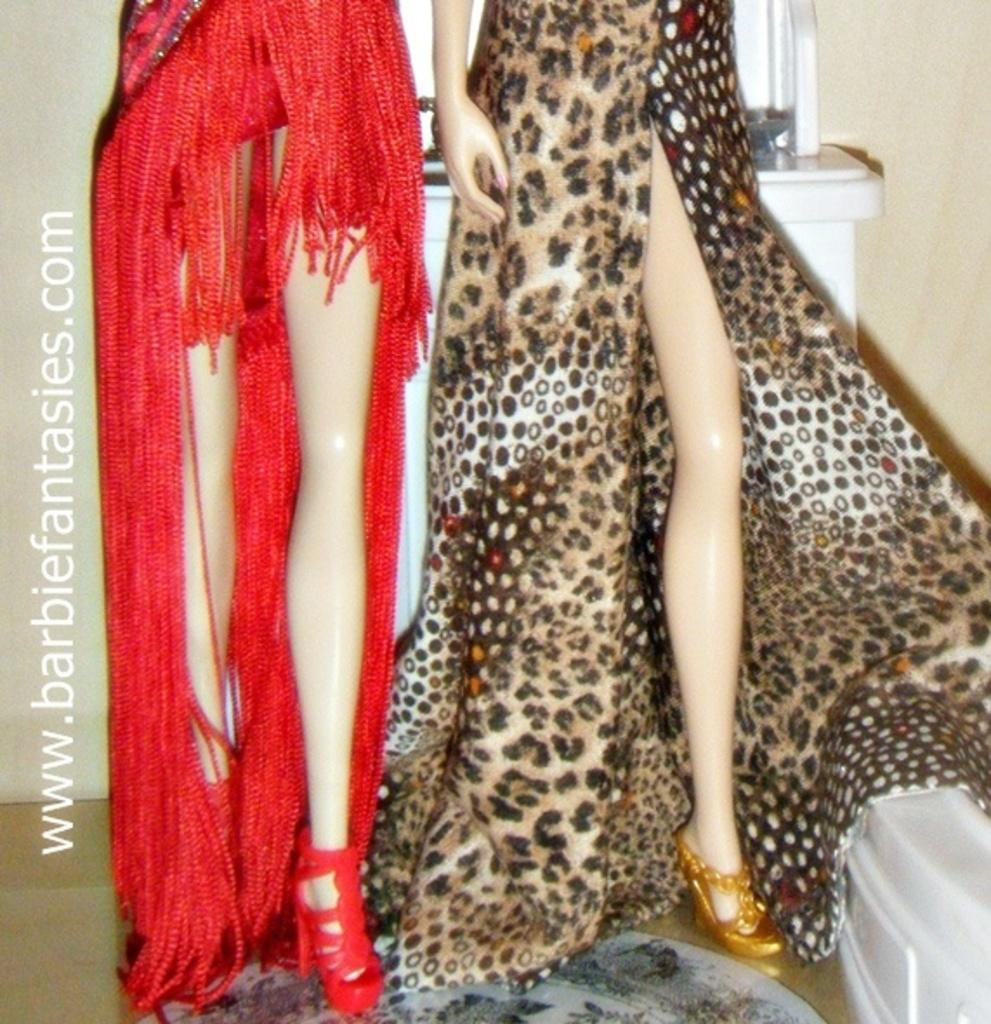How many mannequins are present in the image? There are two women mannequins in the image. Can you describe the object in the right corner of the image? Unfortunately, the facts provided do not give any information about the object in the right corner. What is written in the left corner of the image? The facts provided mention that there is something written in the left corner of the image. Can you tell me how many robins are perched on the mannequins' toes in the image? There are no robins present in the image, and therefore no robins on the mannequins' toes. 